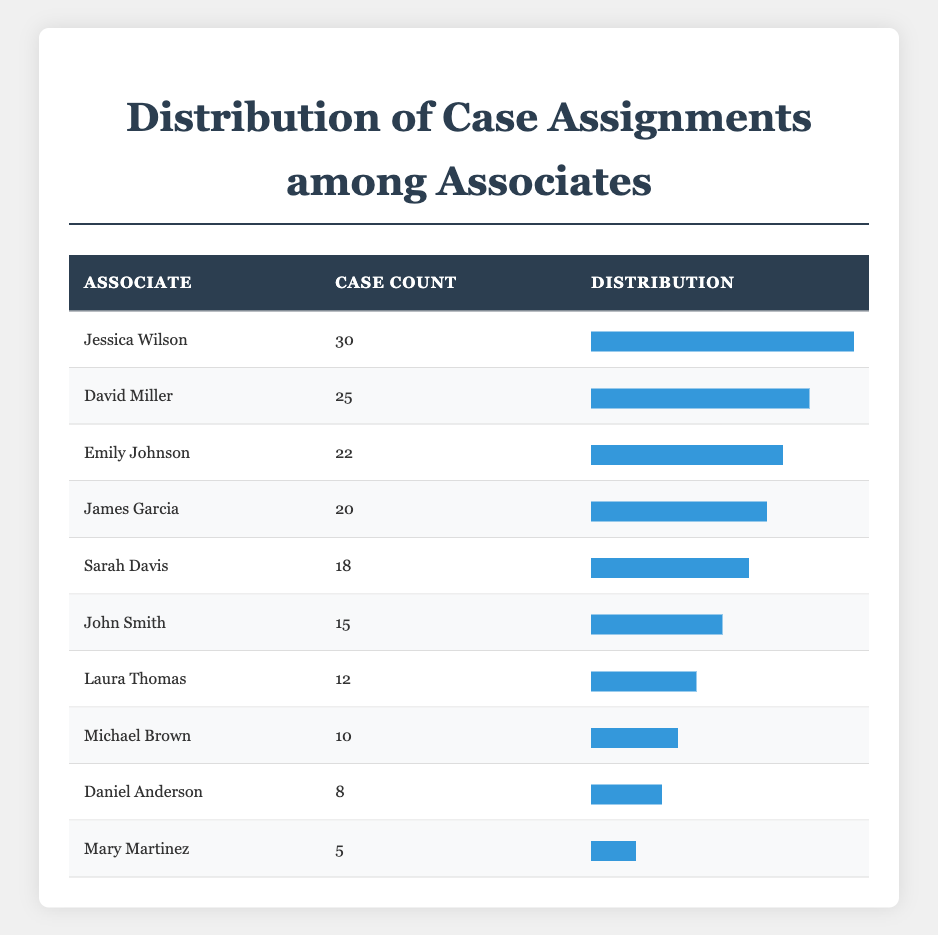What associate has the highest case count? Looking at the case count column, Jessica Wilson has the highest value with 30 cases.
Answer: Jessica Wilson How many cases does David Miller have? The table shows that David Miller has a case count of 25.
Answer: 25 Is it true that Mary Martinez has more than 10 case assignments? Mary Martinez has a case count of 5, which is less than 10, making the statement false.
Answer: No What is the total case count of all associates in the table? We add up the case counts: 15 + 22 + 10 + 18 + 25 + 30 + 8 + 12 + 20 + 5 =  165. Thus, the total case count is 165.
Answer: 165 Which associate has the second highest case count, and how many cases do they have? The second highest case count is held by David Miller with 25 cases.
Answer: David Miller, 25 What is the average number of cases assigned to the associates? To find the average, we first sum the case counts (165) and divide by the number of associates (10), which gives us 165 / 10 = 16.5.
Answer: 16.5 How many associates have more than 15 cases assigned? By reviewing the table, we see that Jessica Wilson, David Miller, Emily Johnson, and James Garcia have more than 15 cases, totaling 4 associates.
Answer: 4 Do less than 20 case counts have more than one associate assigned? The associates with case counts below 20 are Michael Brown (10), Laura Thomas (12), and Daniel Anderson (8) — totaling three associates, hence the statement is true.
Answer: Yes What is the difference between the maximum and minimum case counts? The maximum case count is 30 (Jessica Wilson) and the minimum is 5 (Mary Martinez). The difference is 30 - 5 = 25.
Answer: 25 